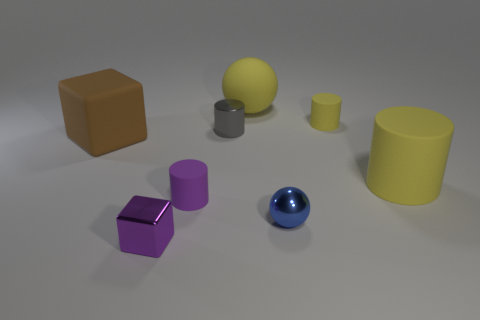Subtract all metallic cylinders. How many cylinders are left? 3 Subtract 1 yellow spheres. How many objects are left? 7 Subtract all spheres. How many objects are left? 6 Subtract 2 cylinders. How many cylinders are left? 2 Subtract all purple cylinders. Subtract all cyan spheres. How many cylinders are left? 3 Subtract all yellow cylinders. How many gray balls are left? 0 Subtract all large purple things. Subtract all small gray shiny cylinders. How many objects are left? 7 Add 7 blue spheres. How many blue spheres are left? 8 Add 8 metallic cubes. How many metallic cubes exist? 9 Add 1 large red metallic cylinders. How many objects exist? 9 